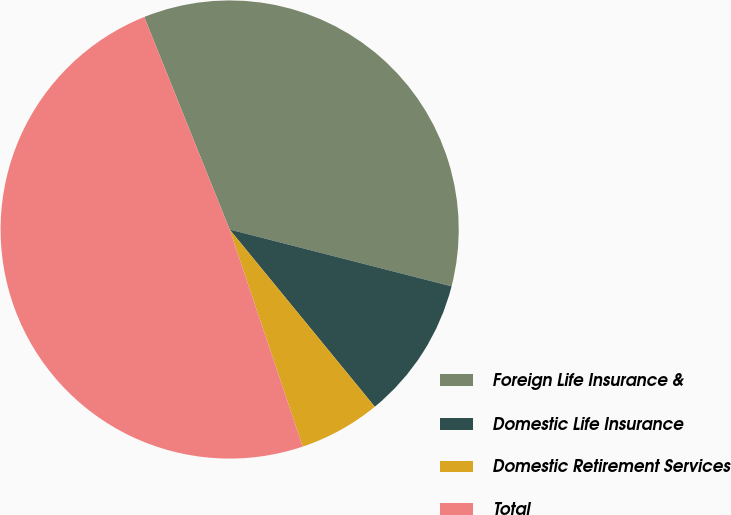Convert chart to OTSL. <chart><loc_0><loc_0><loc_500><loc_500><pie_chart><fcel>Foreign Life Insurance &<fcel>Domestic Life Insurance<fcel>Domestic Retirement Services<fcel>Total<nl><fcel>35.07%<fcel>10.09%<fcel>5.75%<fcel>49.09%<nl></chart> 